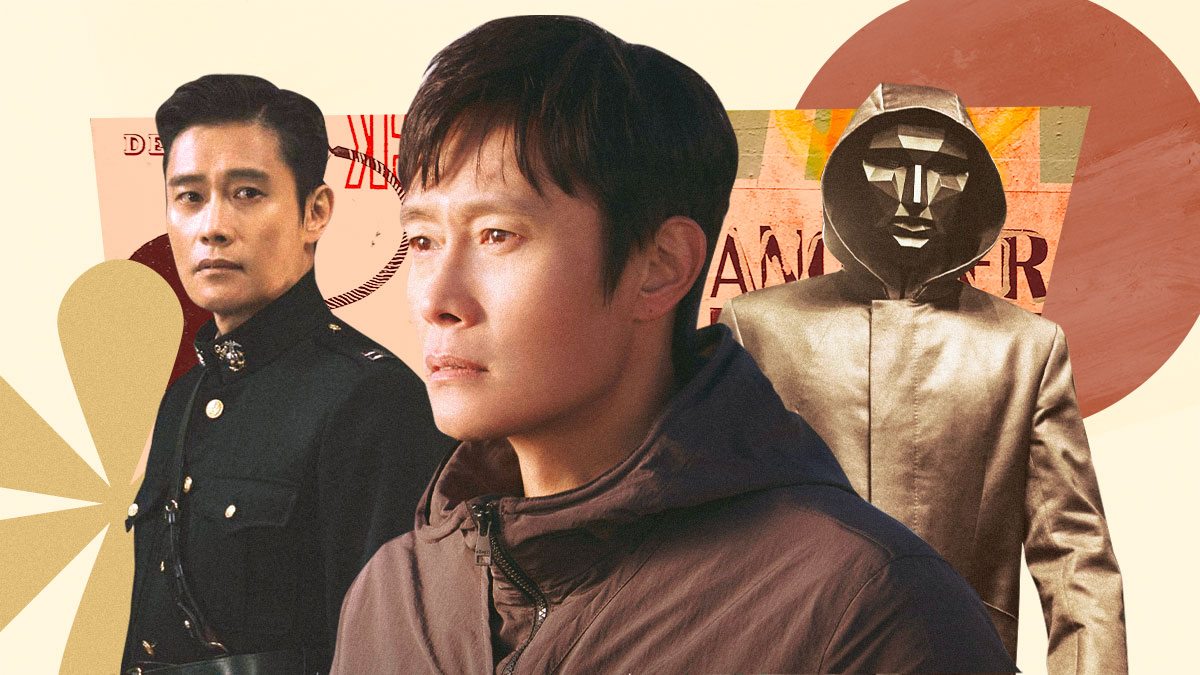What do you see happening in this image? The image showcases a single actor portrayed in multiple roles. On the left, he appears in a ceremonial military outfit, projecting an aura of authority and determination. The middle representation shows him in contemplative civilian attire, suggesting depth and introspection. On the right, he is dressed in a mysterious, hooded costume, adding an element of enigma. The background blends warm tones of orange and yellow, enhancing the prominence of the characters with an artistic touch. 